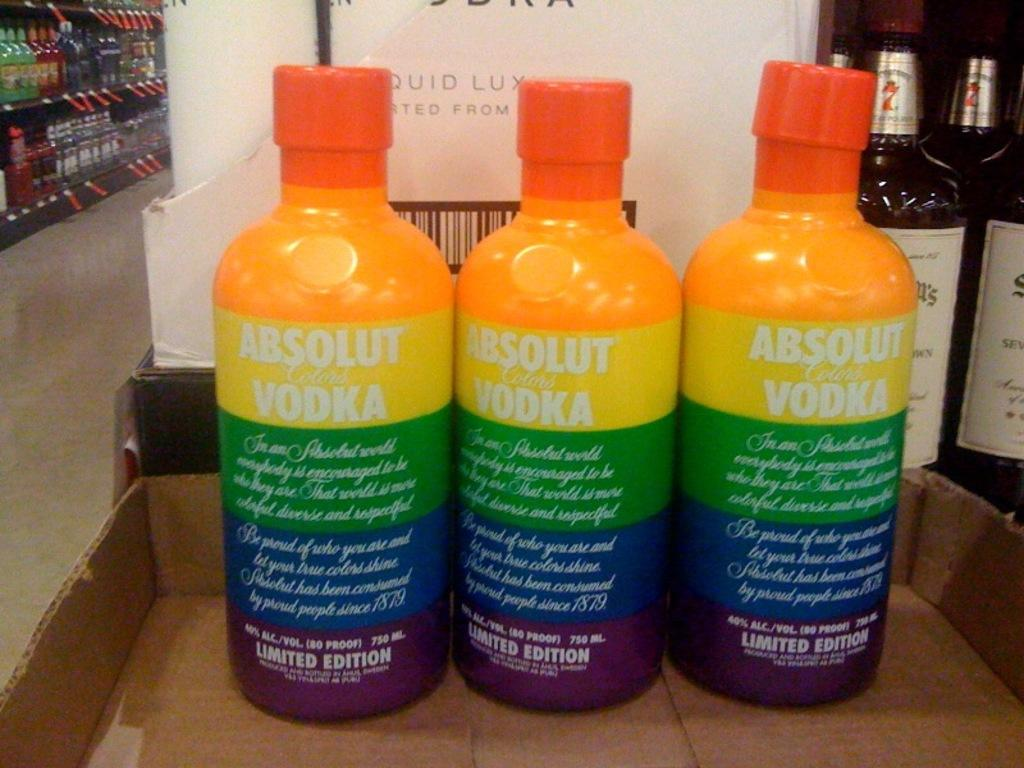<image>
Offer a succinct explanation of the picture presented. three colorful bottles of absolut vodka standing next to each other in a box top 